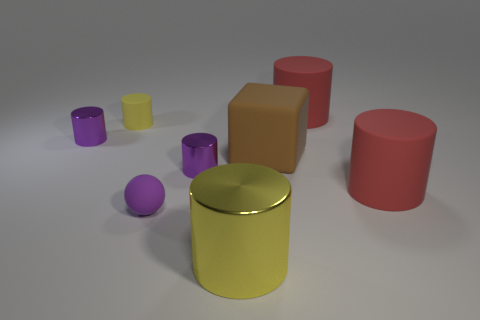There is a rubber object that is the same size as the purple ball; what color is it? yellow 